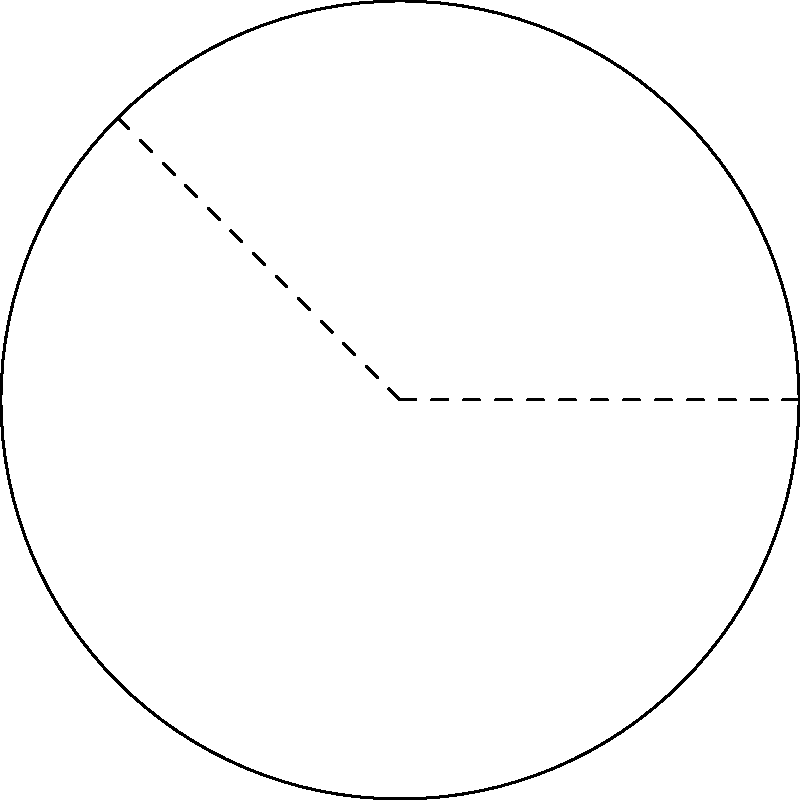A wind turbine blade is being designed for a new green energy project in your town. The blade's tip follows an arc of a circle with radius 50 meters. If the angle subtended by this arc at the center is 135°, what is the length of the blade's tip to the nearest meter? To solve this problem, we'll use the formula for the length of an arc:

Arc Length = $\frac{\theta}{360°} \cdot 2\pi r$

Where:
$\theta$ is the central angle in degrees
$r$ is the radius of the circle

Given:
- Radius (r) = 50 meters
- Central angle ($\theta$) = 135°

Step 1: Substitute the values into the formula:
Arc Length = $\frac{135°}{360°} \cdot 2\pi \cdot 50$

Step 2: Simplify:
Arc Length = $\frac{3}{8} \cdot 2\pi \cdot 50$
           = $\frac{3}{4} \pi \cdot 50$
           = $\frac{150\pi}{4}$
           ≈ 117.8097 meters

Step 3: Round to the nearest meter:
Arc Length ≈ 118 meters
Answer: 118 meters 